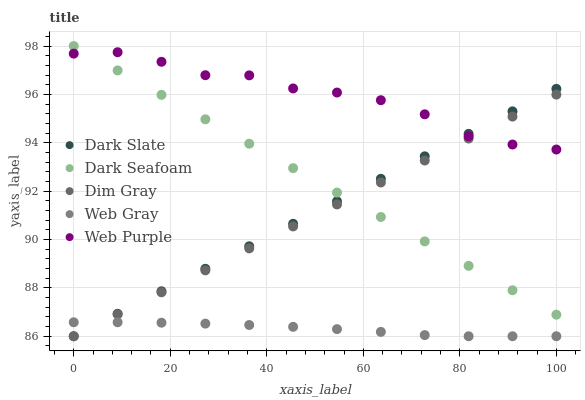Does Web Gray have the minimum area under the curve?
Answer yes or no. Yes. Does Web Purple have the maximum area under the curve?
Answer yes or no. Yes. Does Dark Seafoam have the minimum area under the curve?
Answer yes or no. No. Does Dark Seafoam have the maximum area under the curve?
Answer yes or no. No. Is Dark Slate the smoothest?
Answer yes or no. Yes. Is Web Purple the roughest?
Answer yes or no. Yes. Is Dark Seafoam the smoothest?
Answer yes or no. No. Is Dark Seafoam the roughest?
Answer yes or no. No. Does Dark Slate have the lowest value?
Answer yes or no. Yes. Does Dark Seafoam have the lowest value?
Answer yes or no. No. Does Dark Seafoam have the highest value?
Answer yes or no. Yes. Does Dim Gray have the highest value?
Answer yes or no. No. Is Web Gray less than Dark Seafoam?
Answer yes or no. Yes. Is Web Purple greater than Web Gray?
Answer yes or no. Yes. Does Dark Seafoam intersect Web Purple?
Answer yes or no. Yes. Is Dark Seafoam less than Web Purple?
Answer yes or no. No. Is Dark Seafoam greater than Web Purple?
Answer yes or no. No. Does Web Gray intersect Dark Seafoam?
Answer yes or no. No. 